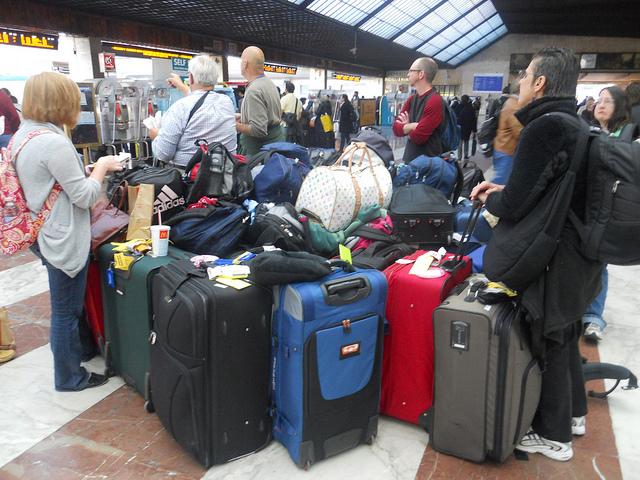Where are these people standing?
Be succinct. Airport. What does the woman on the left have on her back?
Keep it brief. Backpack. What are the things in between the people?
Answer briefly. Suitcases. 